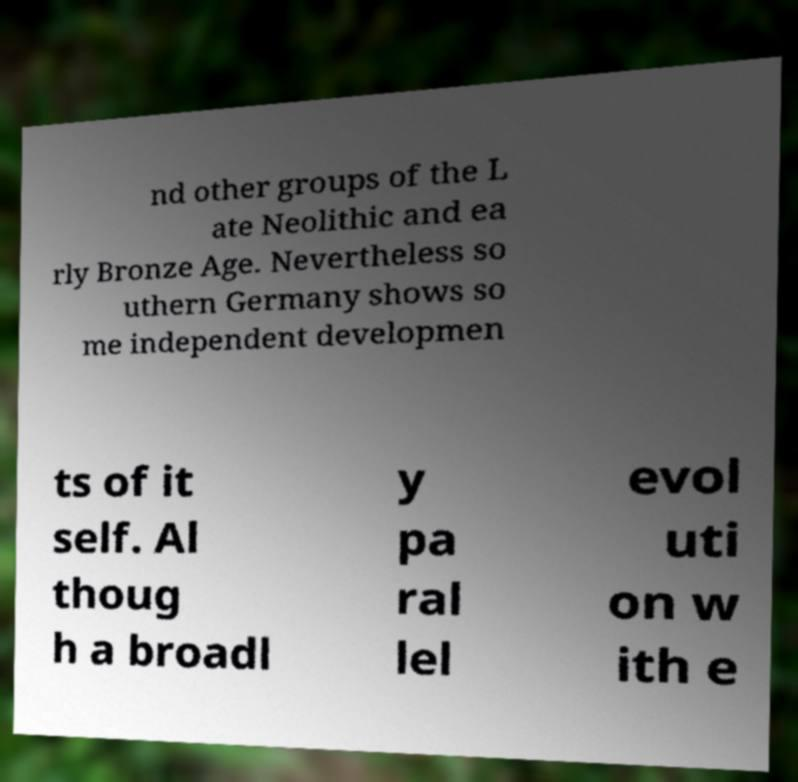Could you extract and type out the text from this image? nd other groups of the L ate Neolithic and ea rly Bronze Age. Nevertheless so uthern Germany shows so me independent developmen ts of it self. Al thoug h a broadl y pa ral lel evol uti on w ith e 